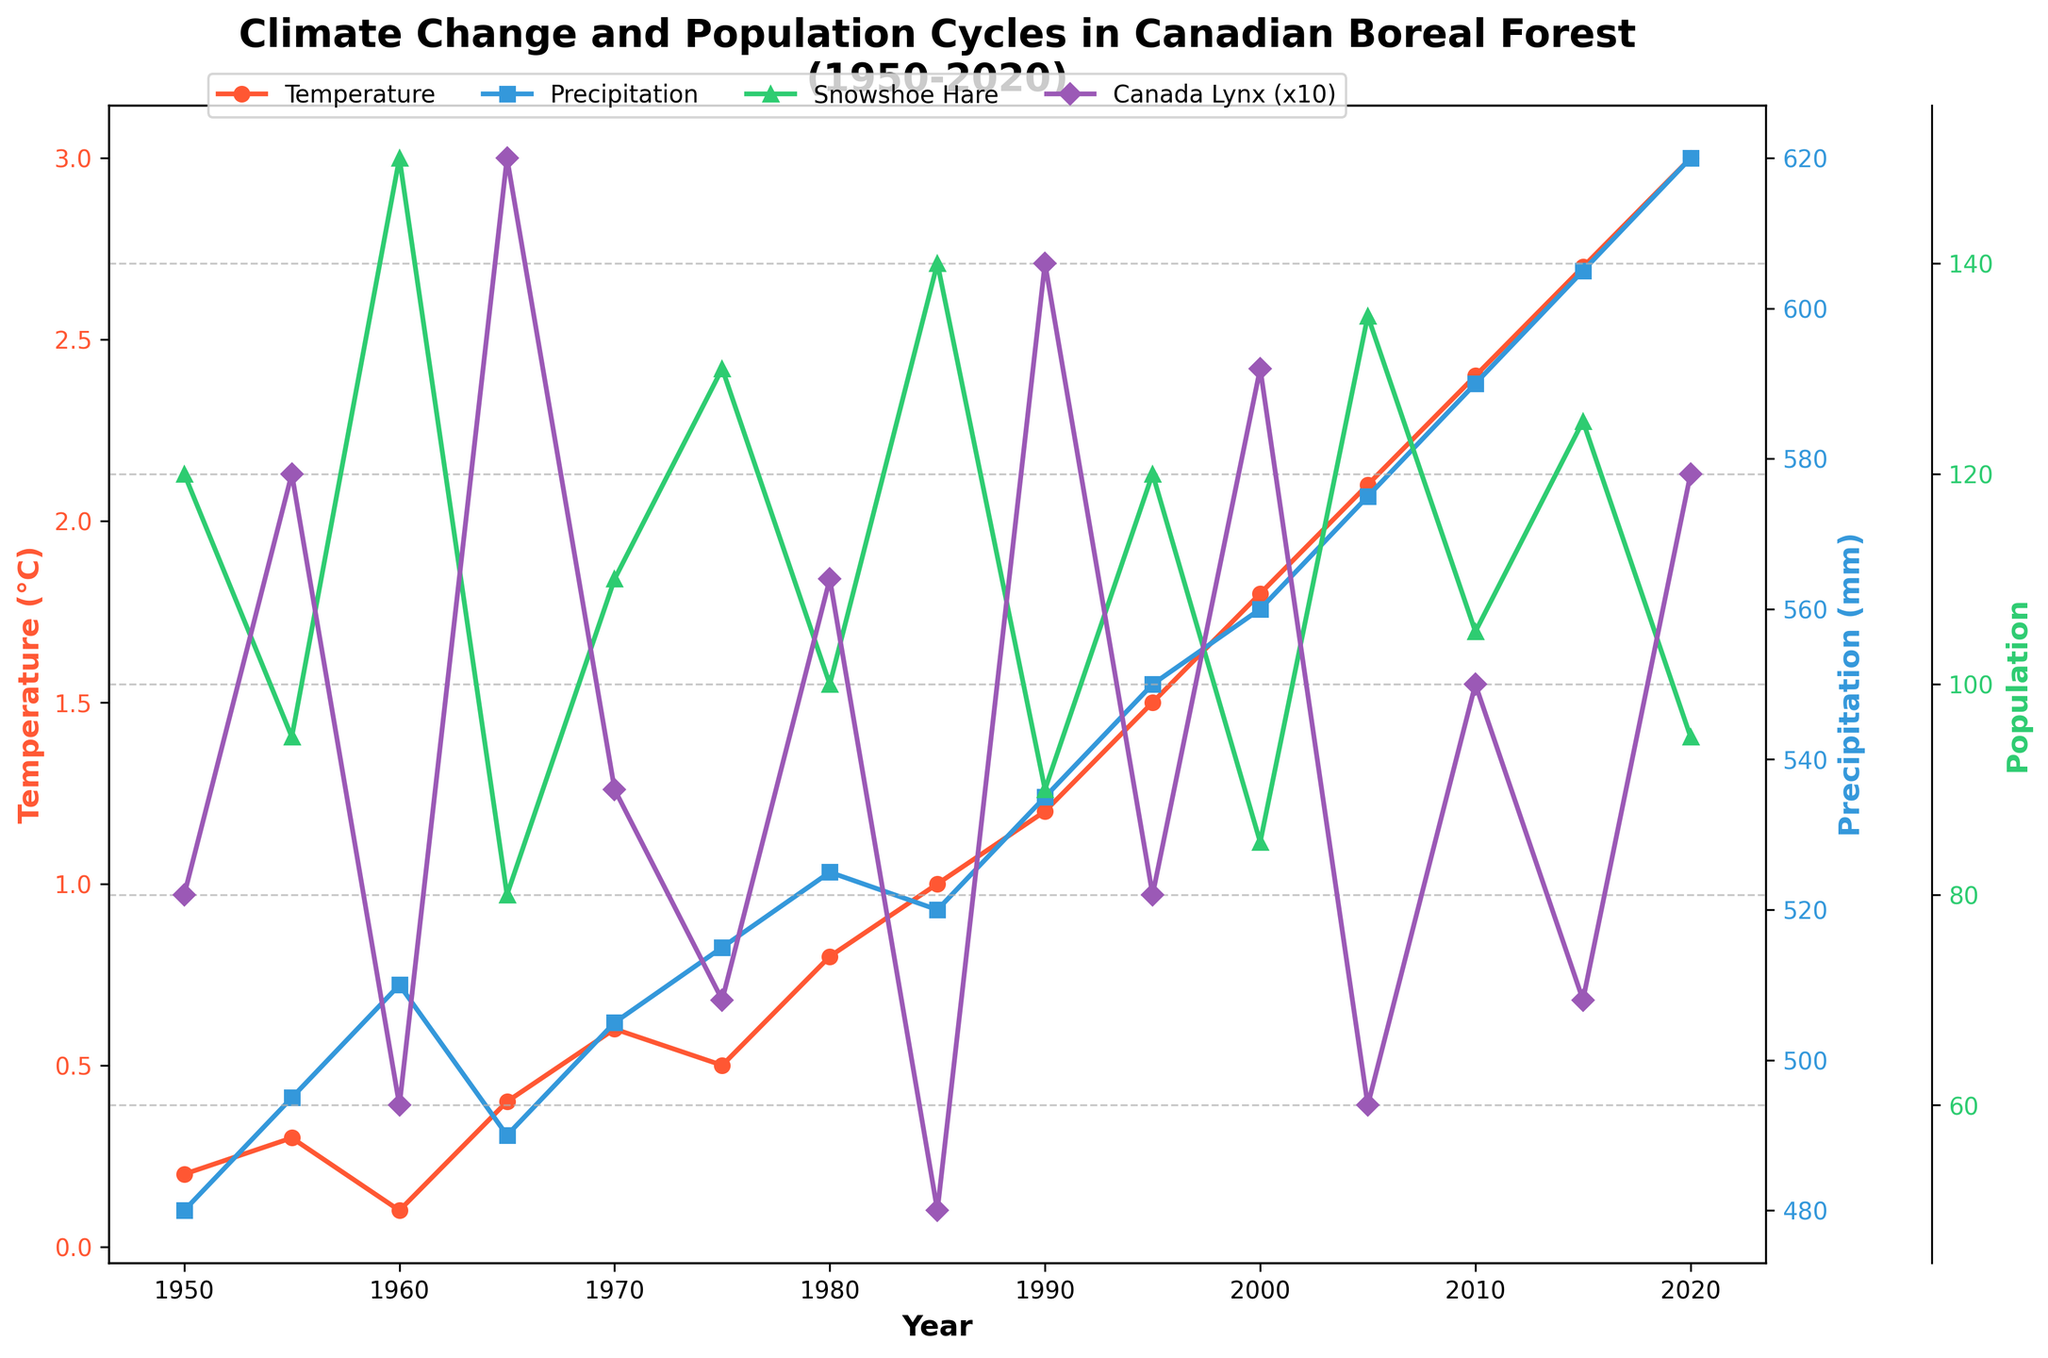What's the average annual temperature in 1970? Look at the line marked with circular markers corresponding to "Temperature" and identify the value for 1970.
Answer: 0.6°C Which year had the highest annual precipitation? Look at the line marked with square markers corresponding to "Precipitation" and find the year with the highest y-axis value.
Answer: 2020 Did the snowshoe hare population increase or decrease from 1985 to 1990? Observe the line marked with triangular markers for "Snowshoe Hare Population" and compare the values from 1985 and 1990.
Answer: Decrease By how much did the average annual temperature increase from 1950 to 2020? Subtract the value in 1950 from the value in 2020 for the temperature line.
Answer: 2.8°C In what year did the population cycles of snowshoe hares and Canada lynx both show a peak? Compare the lines marked with triangles and diamonds to find the year when both populations are highest.
Answer: 1960 What's the average precipitation between 2000 and 2020? Identify the precipitation values for 2000, 2005, 2010, 2015, and 2020. Sum these values and divide by 5 to find the average.
Answer: (560 + 575 + 590 + 605 + 620)/5 = 590 mm When was the snowshoe hare population equal to 120 per km²? Find the intersection point of the "Snowshoe Hare Population" line (triangle markers) with the value 120.
Answer: 1950 and 1995 Compare the temperatures in 1950 and 2000. Which year was warmer? Look at the "Temperature" line and compare the values for 1950 and 2000.
Answer: 2000 How much higher was the lynx population in 1965 compared to 1985 (convert both to the same unit per km²)? Multiply the lynx populations by 10 and subtract the 1985 value from the 1965 value.
Answer: (15*10) - (5*10) = 150 - 50 = 100 per km² Which year had a population drop for both snowshoe hares and Canada lynx from the preceding observed year? Observe the trends for the hare and lynx population lines and identify the year where both populations decrease compared to the previous data point.
Answer: 1965 